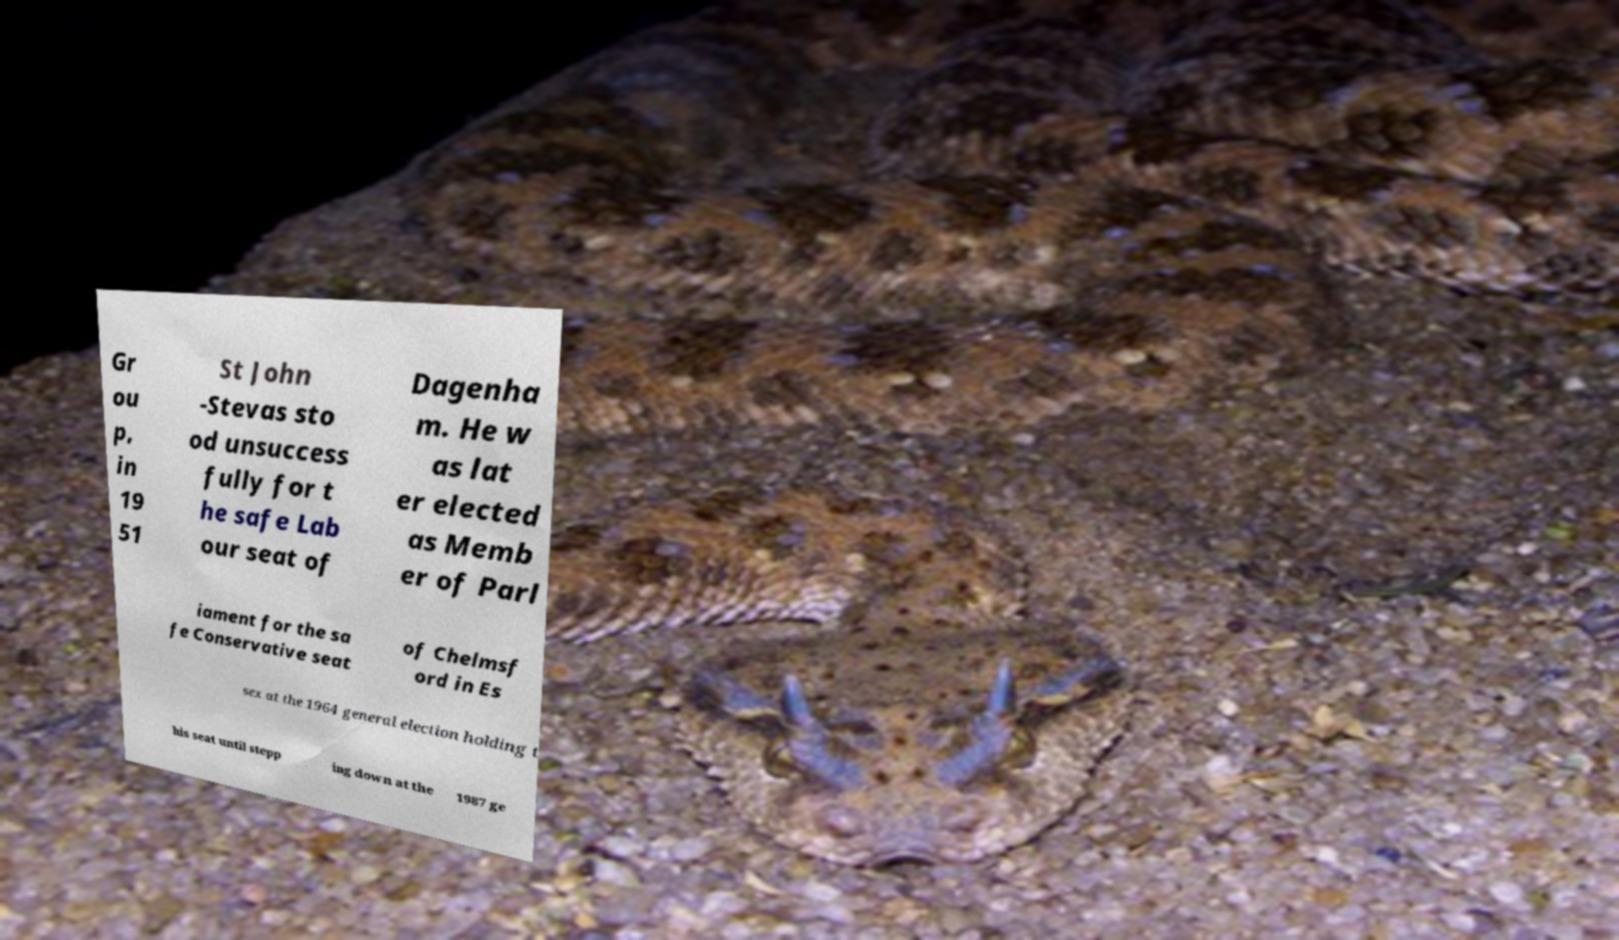Can you accurately transcribe the text from the provided image for me? Gr ou p, in 19 51 St John -Stevas sto od unsuccess fully for t he safe Lab our seat of Dagenha m. He w as lat er elected as Memb er of Parl iament for the sa fe Conservative seat of Chelmsf ord in Es sex at the 1964 general election holding t his seat until stepp ing down at the 1987 ge 